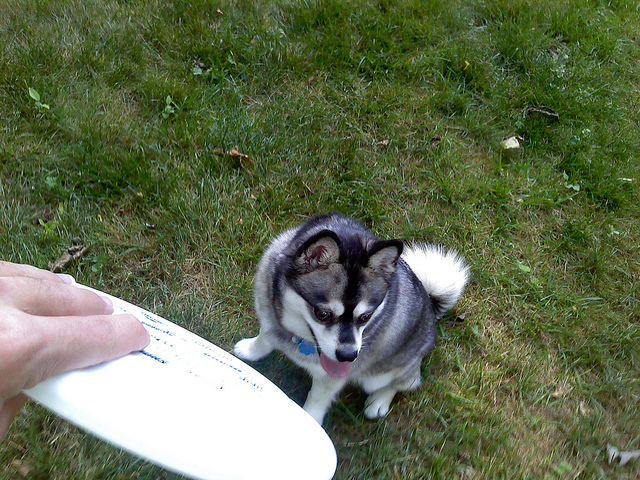<image>What breed is the dog? I am not sure about the breed of the dog. However, it could possibly be a husky or a wolf. What breed is the dog? I am not sure what breed the dog is. It can be a husky or a siberian husky. 